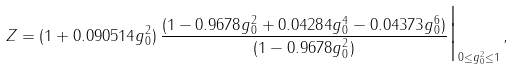<formula> <loc_0><loc_0><loc_500><loc_500>Z = ( 1 + 0 . 0 9 0 5 1 4 g _ { 0 } ^ { 2 } ) \, \frac { ( 1 - 0 . 9 6 7 8 g _ { 0 } ^ { 2 } + 0 . 0 4 2 8 4 g _ { 0 } ^ { 4 } - 0 . 0 4 3 7 3 g _ { 0 } ^ { 6 } ) } { ( 1 - 0 . 9 6 7 8 g _ { 0 } ^ { 2 } ) } \Big | _ { 0 \leq g _ { 0 } ^ { 2 } \leq 1 } \, ,</formula> 